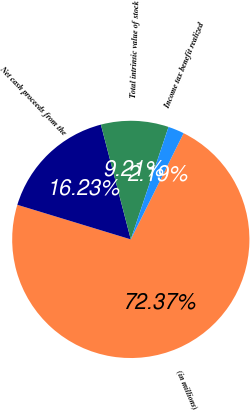<chart> <loc_0><loc_0><loc_500><loc_500><pie_chart><fcel>(in millions)<fcel>Net cash proceeds from the<fcel>Total intrinsic value of stock<fcel>Income tax benefit realized<nl><fcel>72.37%<fcel>16.23%<fcel>9.21%<fcel>2.19%<nl></chart> 